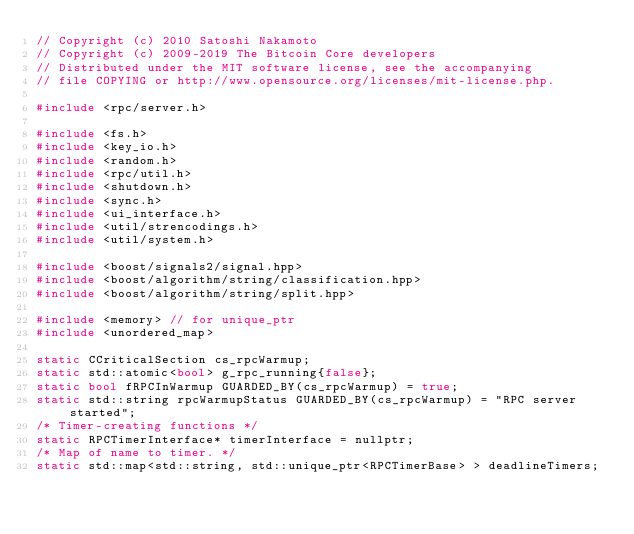Convert code to text. <code><loc_0><loc_0><loc_500><loc_500><_C++_>// Copyright (c) 2010 Satoshi Nakamoto
// Copyright (c) 2009-2019 The Bitcoin Core developers
// Distributed under the MIT software license, see the accompanying
// file COPYING or http://www.opensource.org/licenses/mit-license.php.

#include <rpc/server.h>

#include <fs.h>
#include <key_io.h>
#include <random.h>
#include <rpc/util.h>
#include <shutdown.h>
#include <sync.h>
#include <ui_interface.h>
#include <util/strencodings.h>
#include <util/system.h>

#include <boost/signals2/signal.hpp>
#include <boost/algorithm/string/classification.hpp>
#include <boost/algorithm/string/split.hpp>

#include <memory> // for unique_ptr
#include <unordered_map>

static CCriticalSection cs_rpcWarmup;
static std::atomic<bool> g_rpc_running{false};
static bool fRPCInWarmup GUARDED_BY(cs_rpcWarmup) = true;
static std::string rpcWarmupStatus GUARDED_BY(cs_rpcWarmup) = "RPC server started";
/* Timer-creating functions */
static RPCTimerInterface* timerInterface = nullptr;
/* Map of name to timer. */
static std::map<std::string, std::unique_ptr<RPCTimerBase> > deadlineTimers;
</code> 